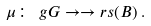Convert formula to latex. <formula><loc_0><loc_0><loc_500><loc_500>\mu \colon \ g G \to \to r s ( B ) \, .</formula> 